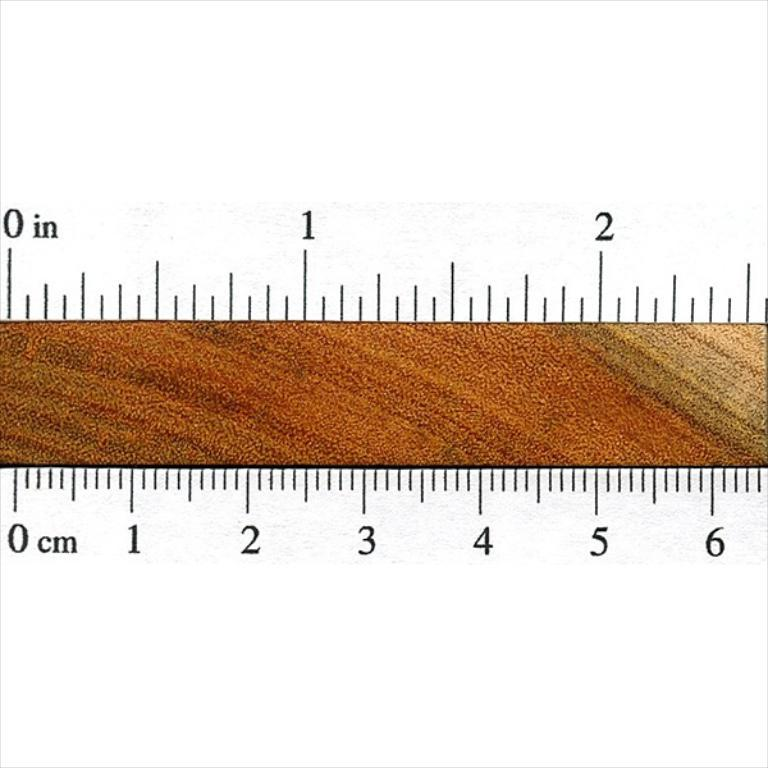Provide a one-sentence caption for the provided image. A measuring device showing the numbers 0 through 6 in cm on the bottom and numbers 0 through 2 in on the top. 